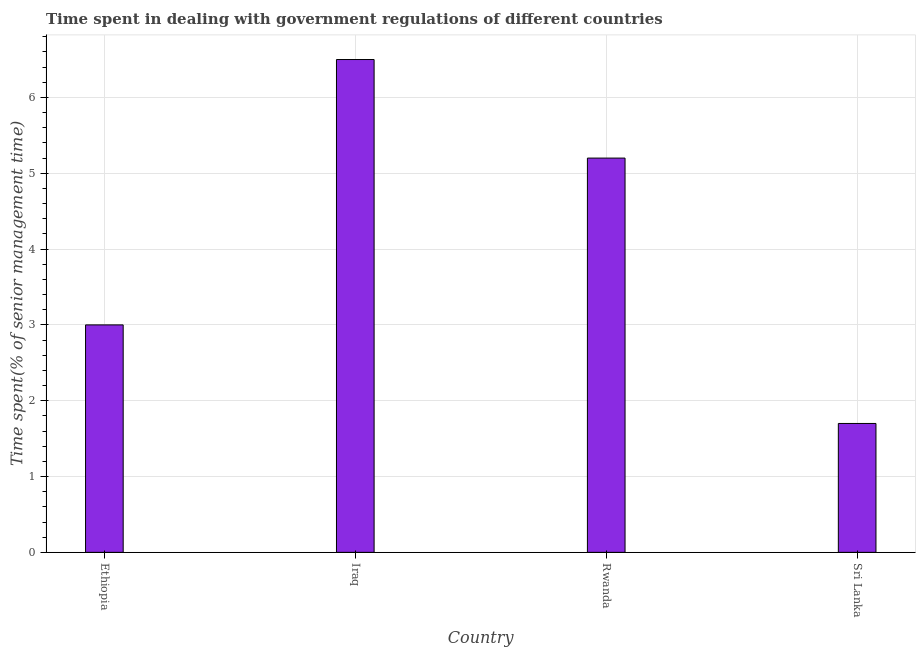Does the graph contain any zero values?
Provide a short and direct response. No. What is the title of the graph?
Your answer should be compact. Time spent in dealing with government regulations of different countries. What is the label or title of the X-axis?
Provide a short and direct response. Country. What is the label or title of the Y-axis?
Your response must be concise. Time spent(% of senior management time). What is the time spent in dealing with government regulations in Sri Lanka?
Your response must be concise. 1.7. Across all countries, what is the minimum time spent in dealing with government regulations?
Your answer should be compact. 1.7. In which country was the time spent in dealing with government regulations maximum?
Make the answer very short. Iraq. In which country was the time spent in dealing with government regulations minimum?
Provide a short and direct response. Sri Lanka. What is the sum of the time spent in dealing with government regulations?
Give a very brief answer. 16.4. In how many countries, is the time spent in dealing with government regulations greater than 0.2 %?
Offer a terse response. 4. Is the sum of the time spent in dealing with government regulations in Ethiopia and Iraq greater than the maximum time spent in dealing with government regulations across all countries?
Provide a short and direct response. Yes. What is the difference between the highest and the lowest time spent in dealing with government regulations?
Offer a very short reply. 4.8. In how many countries, is the time spent in dealing with government regulations greater than the average time spent in dealing with government regulations taken over all countries?
Keep it short and to the point. 2. What is the difference between two consecutive major ticks on the Y-axis?
Your response must be concise. 1. What is the Time spent(% of senior management time) of Sri Lanka?
Your response must be concise. 1.7. What is the difference between the Time spent(% of senior management time) in Iraq and Rwanda?
Give a very brief answer. 1.3. What is the difference between the Time spent(% of senior management time) in Rwanda and Sri Lanka?
Your response must be concise. 3.5. What is the ratio of the Time spent(% of senior management time) in Ethiopia to that in Iraq?
Provide a succinct answer. 0.46. What is the ratio of the Time spent(% of senior management time) in Ethiopia to that in Rwanda?
Offer a terse response. 0.58. What is the ratio of the Time spent(% of senior management time) in Ethiopia to that in Sri Lanka?
Offer a very short reply. 1.76. What is the ratio of the Time spent(% of senior management time) in Iraq to that in Sri Lanka?
Provide a succinct answer. 3.82. What is the ratio of the Time spent(% of senior management time) in Rwanda to that in Sri Lanka?
Your answer should be compact. 3.06. 